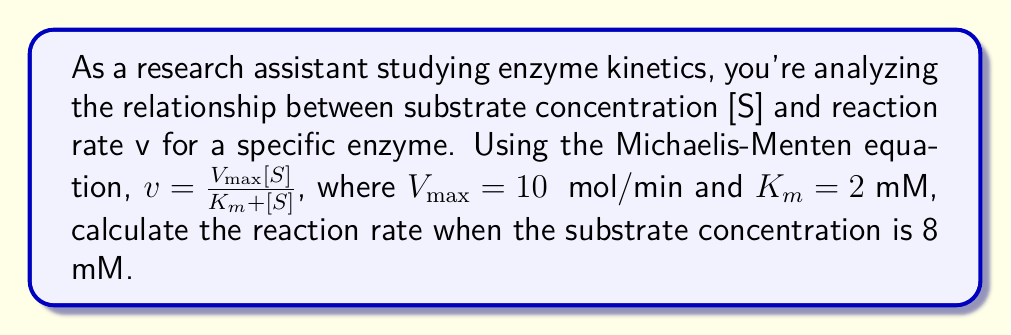Help me with this question. To solve this problem, we'll use the given Michaelis-Menten equation and the provided values:

1. Given information:
   $V_{max} = 10$ μmol/min
   $K_m = 2$ mM
   $[S] = 8$ mM

2. Michaelis-Menten equation:
   $v = \frac{V_{max}[S]}{K_m + [S]}$

3. Substitute the given values into the equation:
   $v = \frac{10 \cdot 8}{2 + 8}$

4. Simplify the numerator:
   $v = \frac{80}{2 + 8}$

5. Simplify the denominator:
   $v = \frac{80}{10}$

6. Perform the division:
   $v = 8$ μmol/min

Therefore, the reaction rate when the substrate concentration is 8 mM is 8 μmol/min.
Answer: 8 μmol/min 